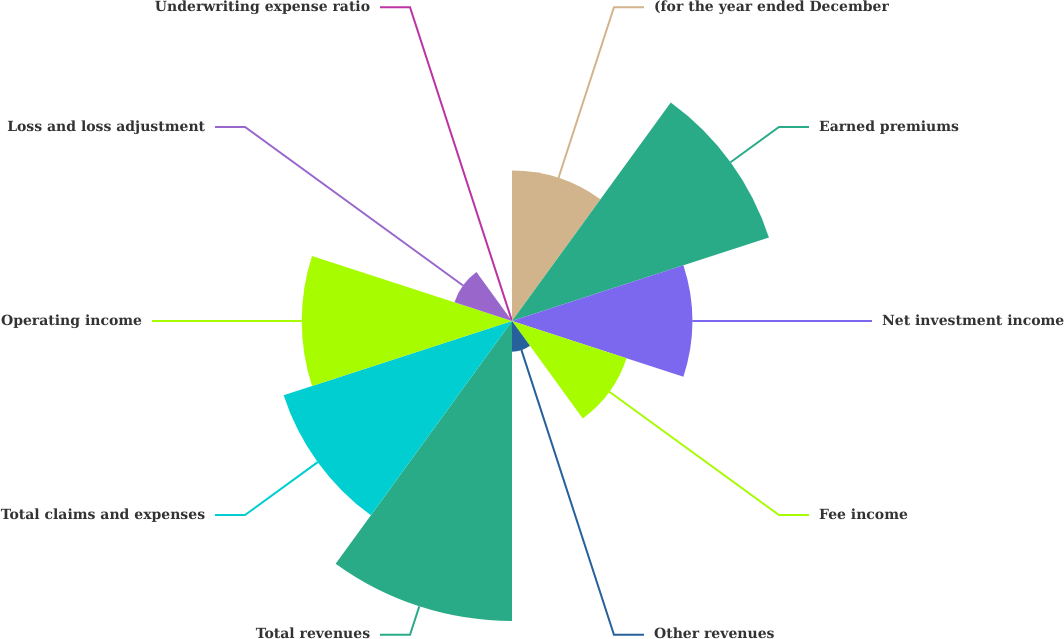Convert chart. <chart><loc_0><loc_0><loc_500><loc_500><pie_chart><fcel>(for the year ended December<fcel>Earned premiums<fcel>Net investment income<fcel>Fee income<fcel>Other revenues<fcel>Total revenues<fcel>Total claims and expenses<fcel>Operating income<fcel>Loss and loss adjustment<fcel>Underwriting expense ratio<nl><fcel>9.62%<fcel>17.28%<fcel>11.53%<fcel>7.7%<fcel>1.96%<fcel>19.19%<fcel>15.36%<fcel>13.45%<fcel>3.87%<fcel>0.04%<nl></chart> 